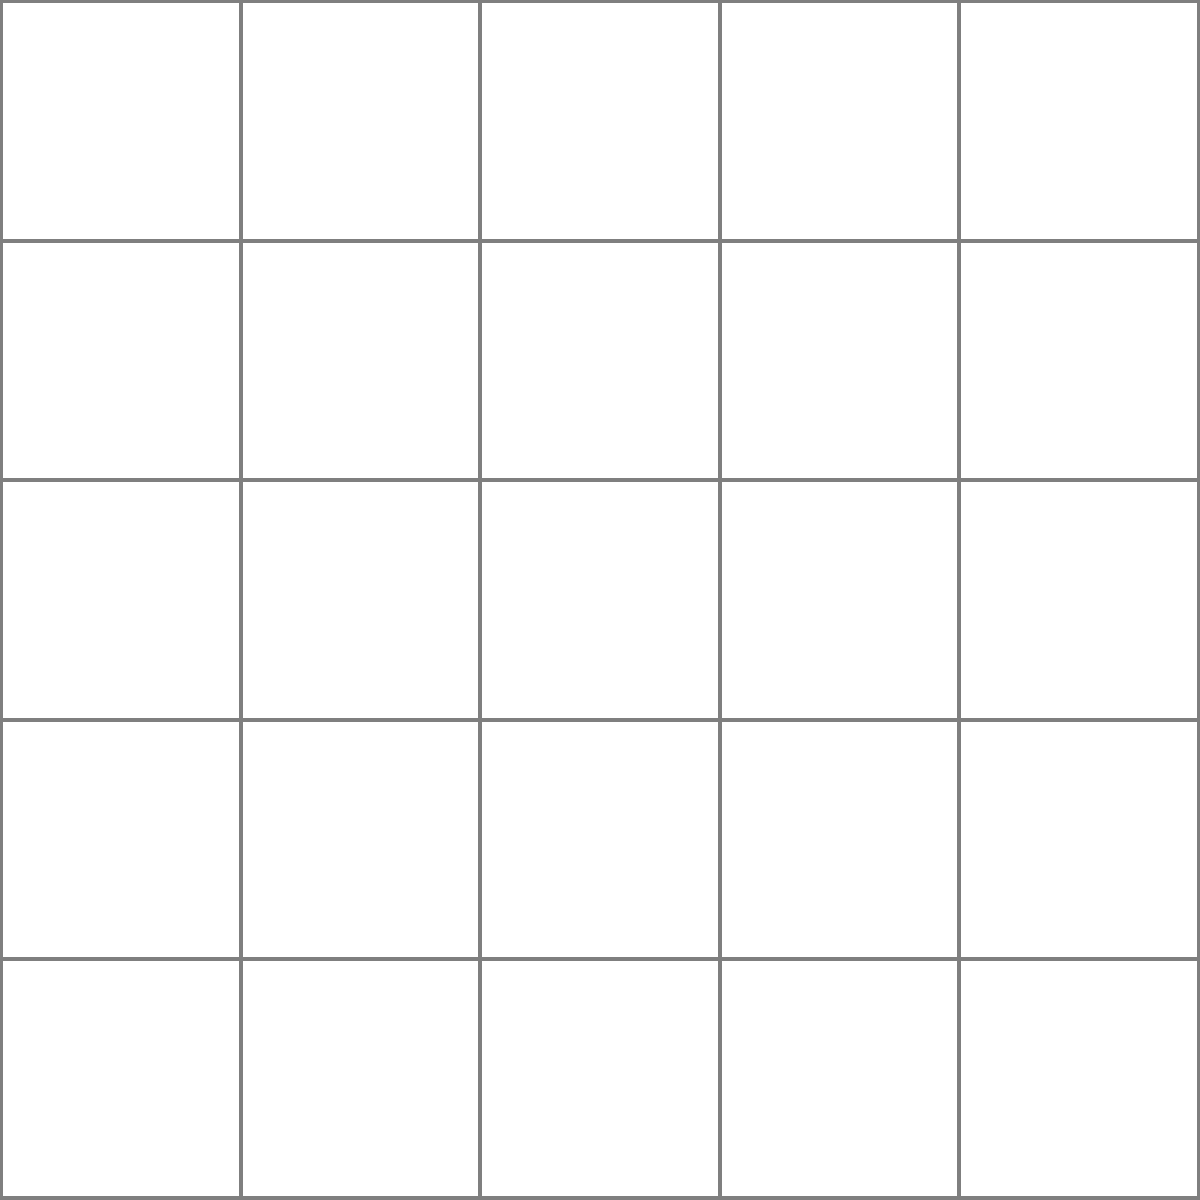In a ship's cargo hold, containers are arranged in a 5x5 grid system, with columns labeled 1-5 and rows labeled A-E. Three containers (X, Y, and Z) need to be retrieved. Using the coordinate system (column, row), what is the sum of the column numbers for all three containers? To solve this problem, we need to identify the positions of containers X, Y, and Z using the given coordinate system, then sum up their column numbers. Let's break it down step-by-step:

1. Identify the positions of the containers:
   - Container X is in column 1, row D (1, D)
   - Container Y is in column 3, row B (3, B)
   - Container Z is in column 4, row E (4, E)

2. Extract the column numbers:
   - Container X: 1
   - Container Y: 3
   - Container Z: 4

3. Sum up the column numbers:
   $1 + 3 + 4 = 8$

Therefore, the sum of the column numbers for all three containers is 8.
Answer: 8 